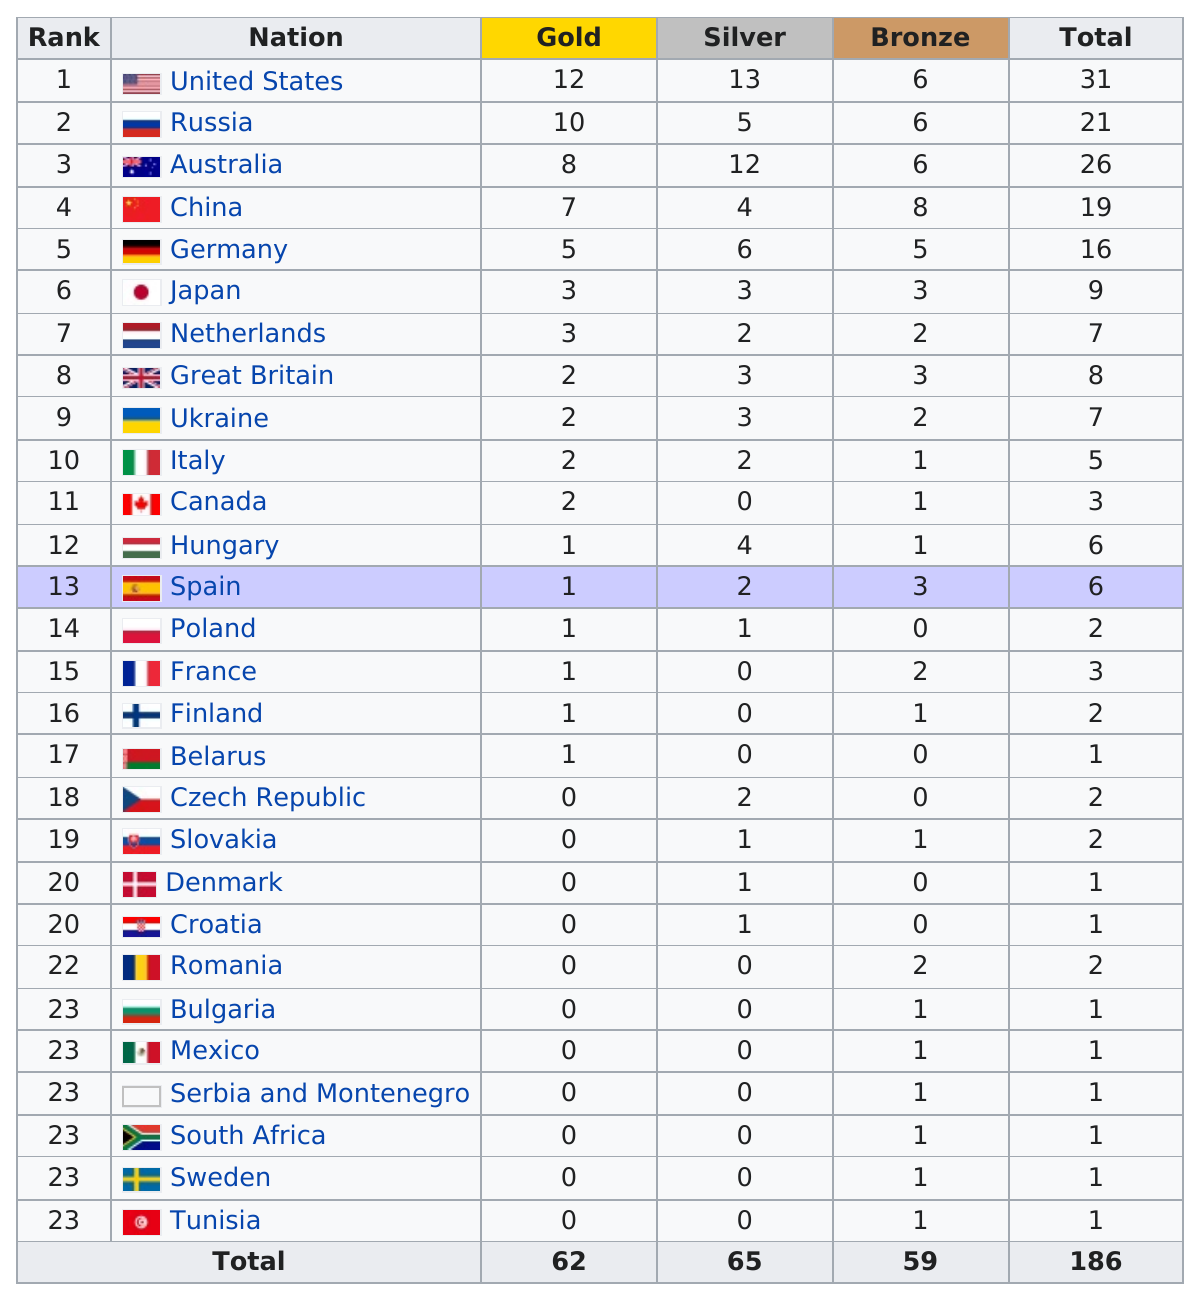Give some essential details in this illustration. The average silver medal count of the first five ranked nations is 8. Russian won four more silver medals than Denmark. Tunisia is the last country on the table. China is the country that has won the largest number of bronze medals. The winner of the largest number of bronze medals is China. 